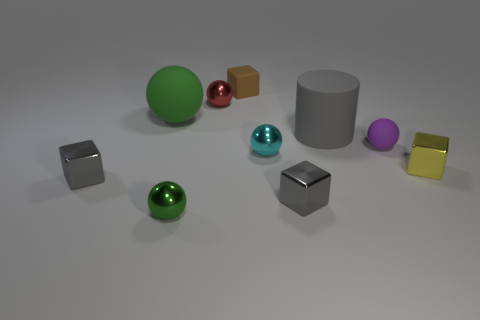What color is the other matte thing that is the same shape as the green rubber object?
Give a very brief answer. Purple. There is a rubber thing to the left of the small red metallic sphere; does it have the same color as the tiny rubber block?
Ensure brevity in your answer.  No. What shape is the tiny metallic object that is the same color as the large ball?
Offer a very short reply. Sphere. What number of things are the same material as the small brown block?
Your response must be concise. 3. There is a tiny yellow block; how many large gray objects are to the right of it?
Your answer should be very brief. 0. What is the size of the brown block?
Make the answer very short. Small. The matte sphere that is the same size as the yellow cube is what color?
Your answer should be compact. Purple. Are there any large spheres of the same color as the small matte cube?
Keep it short and to the point. No. What is the material of the cyan thing?
Offer a terse response. Metal. How many tiny blue cylinders are there?
Ensure brevity in your answer.  0. 